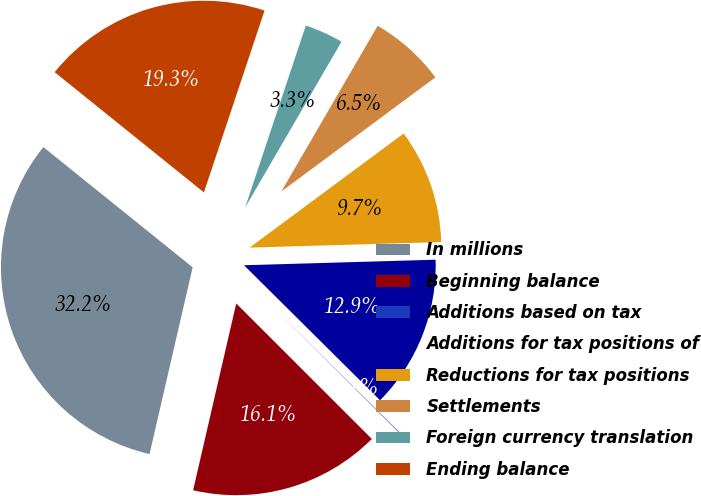<chart> <loc_0><loc_0><loc_500><loc_500><pie_chart><fcel>In millions<fcel>Beginning balance<fcel>Additions based on tax<fcel>Additions for tax positions of<fcel>Reductions for tax positions<fcel>Settlements<fcel>Foreign currency translation<fcel>Ending balance<nl><fcel>32.18%<fcel>16.12%<fcel>0.05%<fcel>12.9%<fcel>9.69%<fcel>6.47%<fcel>3.26%<fcel>19.33%<nl></chart> 